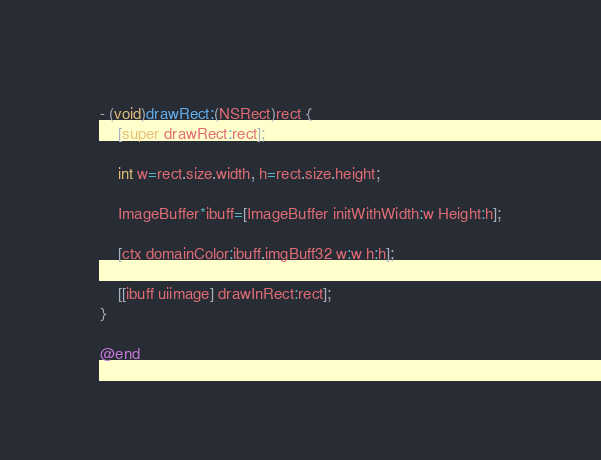<code> <loc_0><loc_0><loc_500><loc_500><_ObjectiveC_>- (void)drawRect:(NSRect)rect {
    [super drawRect:rect];
 
    int w=rect.size.width, h=rect.size.height;
    
    ImageBuffer*ibuff=[ImageBuffer initWithWidth:w Height:h];

    [ctx domainColor:ibuff.imgBuff32 w:w h:h];

    [[ibuff uiimage] drawInRect:rect];
}

@end
</code> 